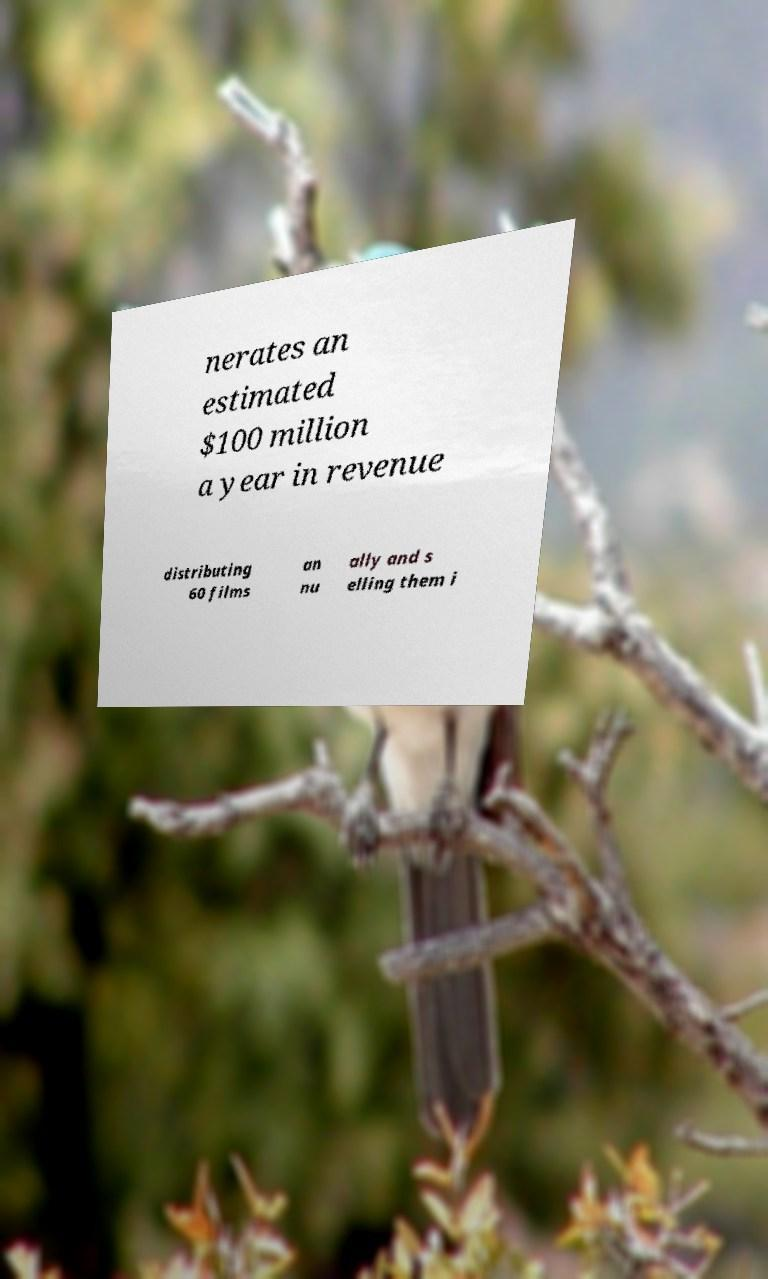Can you read and provide the text displayed in the image?This photo seems to have some interesting text. Can you extract and type it out for me? nerates an estimated $100 million a year in revenue distributing 60 films an nu ally and s elling them i 